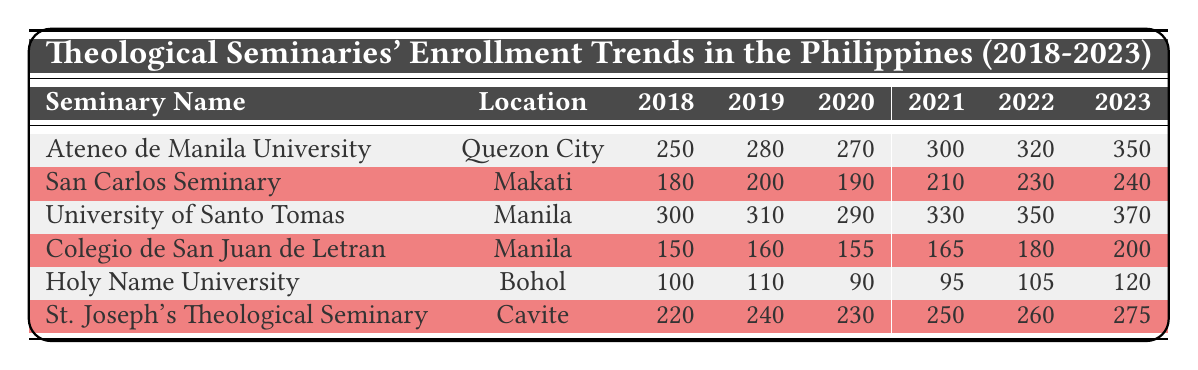What was the enrollment of Ateneo de Manila University in 2020? According to the table, Ateneo de Manila University's enrollment in 2020 is 270.
Answer: 270 What was the total enrollment for University of Santo Tomas from 2018 to 2023? To find the total enrollment from 2018 to 2023 for University of Santo Tomas, add the enrollment values: 300 + 310 + 290 + 330 + 350 + 370 = 1950.
Answer: 1950 Which seminary had the highest enrollment in 2023? The table shows that University of Santo Tomas had the highest enrollment in 2023 with 370 students.
Answer: 370 Did San Carlos Seminary's enrollment decrease from 2019 to 2020? According to the table, San Carlos Seminary's enrollment in 2019 was 200 and in 2020 it was 190, which indicates a decrease.
Answer: Yes What is the average enrollment for Holy Name University over the years from 2018 to 2023? The enrollment figures for Holy Name University are: 100, 110, 90, 95, 105, and 120. Summing these gives 100 + 110 + 90 + 95 + 105 + 120 = 620. There are 6 years, so the average enrollment is 620 / 6 ≈ 103.33.
Answer: Approximately 103.33 What was the increase in enrollment for Colegio de San Juan de Letran from 2018 to 2023? The initial enrollment in 2018 was 150, and in 2023 it increased to 200. The increase can be calculated as 200 - 150 = 50.
Answer: 50 How many seminaries had an enrollment of over 300 in 2022? According to the table, only Ateneo de Manila University (320) and University of Santo Tomas (350) had enrollments greater than 300 in 2022. Thus, there are 2 seminaries.
Answer: 2 Which seminary experienced the least growth from 2018 to 2023 in terms of absolute enrollment? Looking at the data, Holy Name University grew from 100 in 2018 to 120 in 2023, an increase of only 20 students, which is the smallest growth compared to the others.
Answer: Holy Name University 